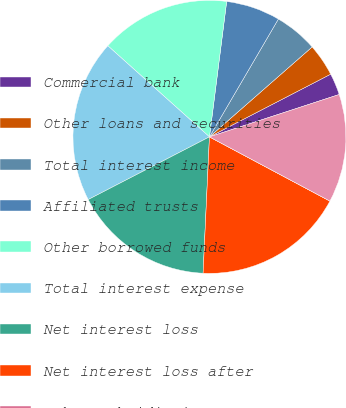<chart> <loc_0><loc_0><loc_500><loc_500><pie_chart><fcel>Commercial bank<fcel>Other loans and securities<fcel>Total interest income<fcel>Affiliated trusts<fcel>Other borrowed funds<fcel>Total interest expense<fcel>Net interest loss<fcel>Net interest loss after<fcel>Other subsidiaries<fcel>Equity and fixed income<nl><fcel>2.57%<fcel>3.85%<fcel>5.13%<fcel>6.41%<fcel>15.38%<fcel>19.23%<fcel>16.66%<fcel>17.95%<fcel>0.0%<fcel>12.82%<nl></chart> 